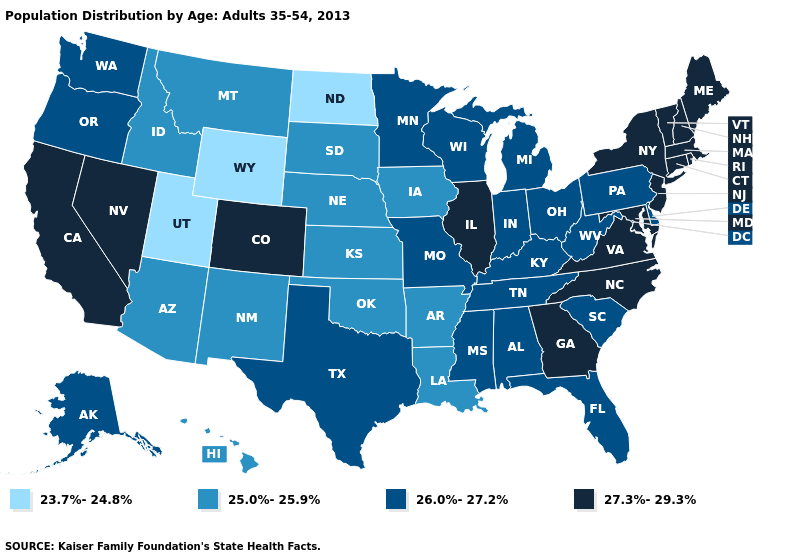Is the legend a continuous bar?
Short answer required. No. What is the value of Kansas?
Concise answer only. 25.0%-25.9%. Name the states that have a value in the range 25.0%-25.9%?
Keep it brief. Arizona, Arkansas, Hawaii, Idaho, Iowa, Kansas, Louisiana, Montana, Nebraska, New Mexico, Oklahoma, South Dakota. What is the value of West Virginia?
Quick response, please. 26.0%-27.2%. Does the first symbol in the legend represent the smallest category?
Be succinct. Yes. Name the states that have a value in the range 25.0%-25.9%?
Give a very brief answer. Arizona, Arkansas, Hawaii, Idaho, Iowa, Kansas, Louisiana, Montana, Nebraska, New Mexico, Oklahoma, South Dakota. Name the states that have a value in the range 25.0%-25.9%?
Be succinct. Arizona, Arkansas, Hawaii, Idaho, Iowa, Kansas, Louisiana, Montana, Nebraska, New Mexico, Oklahoma, South Dakota. Name the states that have a value in the range 27.3%-29.3%?
Be succinct. California, Colorado, Connecticut, Georgia, Illinois, Maine, Maryland, Massachusetts, Nevada, New Hampshire, New Jersey, New York, North Carolina, Rhode Island, Vermont, Virginia. Name the states that have a value in the range 23.7%-24.8%?
Answer briefly. North Dakota, Utah, Wyoming. What is the value of New Mexico?
Answer briefly. 25.0%-25.9%. What is the highest value in the MidWest ?
Concise answer only. 27.3%-29.3%. What is the value of Hawaii?
Quick response, please. 25.0%-25.9%. Name the states that have a value in the range 23.7%-24.8%?
Be succinct. North Dakota, Utah, Wyoming. Which states have the lowest value in the South?
Keep it brief. Arkansas, Louisiana, Oklahoma. 